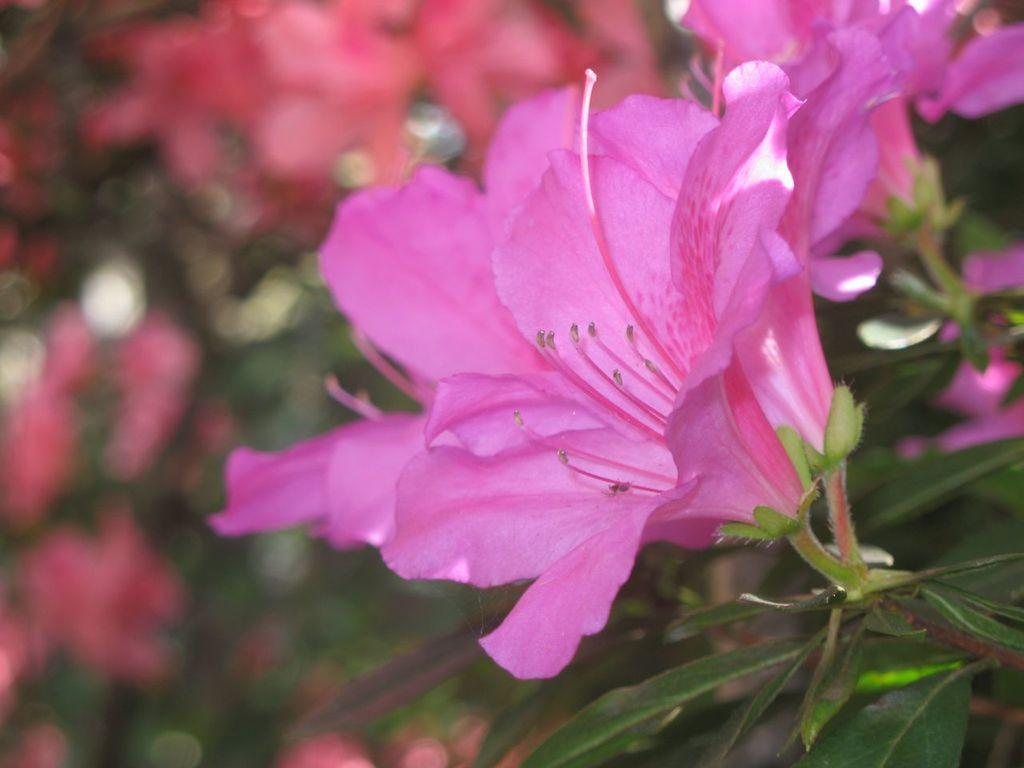What color are the flowers in the image? The flowers in the image are pink. What are the flowers growing on? The flowers are on plants. What type of vest can be seen hanging on the wire in the image? There is no vest or wire present in the image; it only features pink color flowers on plants. 